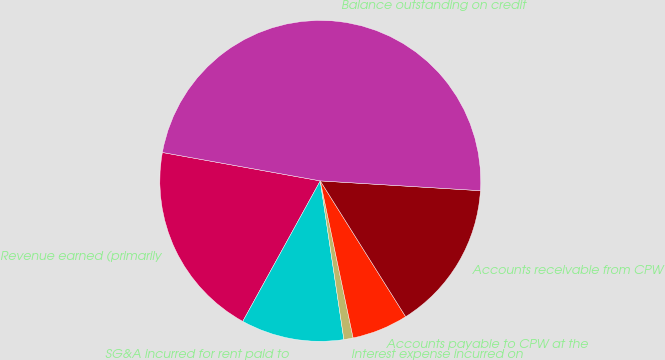Convert chart. <chart><loc_0><loc_0><loc_500><loc_500><pie_chart><fcel>Revenue earned (primarily<fcel>SG&A incurred for rent paid to<fcel>Interest expense incurred on<fcel>Accounts payable to CPW at the<fcel>Accounts receivable from CPW<fcel>Balance outstanding on credit<nl><fcel>19.81%<fcel>10.37%<fcel>0.93%<fcel>5.65%<fcel>15.09%<fcel>48.13%<nl></chart> 